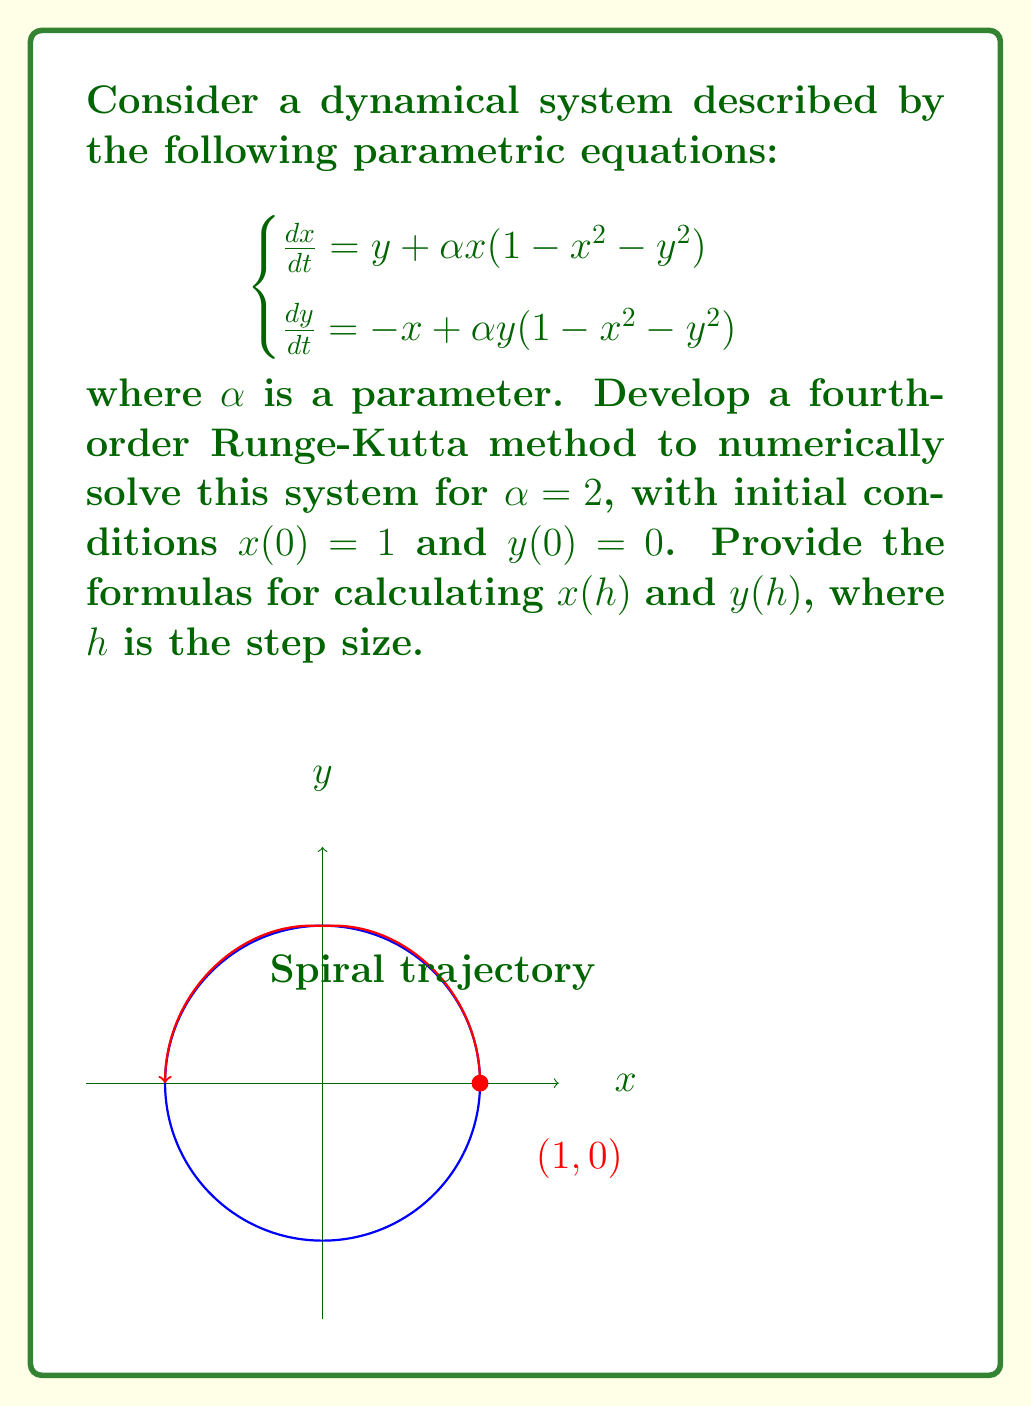Teach me how to tackle this problem. To solve this system using the fourth-order Runge-Kutta method, we follow these steps:

1) Define the functions for $\frac{dx}{dt}$ and $\frac{dy}{dt}$:
   $$f(x,y) = y + 2x(1-x^2-y^2)$$
   $$g(x,y) = -x + 2y(1-x^2-y^2)$$

2) The fourth-order Runge-Kutta method for a system of two equations is given by:
   $$x(t+h) = x(t) + \frac{1}{6}(k_1 + 2k_2 + 2k_3 + k_4)$$
   $$y(t+h) = y(t) + \frac{1}{6}(l_1 + 2l_2 + 2l_3 + l_4)$$

   where:
   $$k_1 = hf(x,y)$$
   $$l_1 = hg(x,y)$$
   $$k_2 = hf(x+\frac{1}{2}k_1, y+\frac{1}{2}l_1)$$
   $$l_2 = hg(x+\frac{1}{2}k_1, y+\frac{1}{2}l_1)$$
   $$k_3 = hf(x+\frac{1}{2}k_2, y+\frac{1}{2}l_2)$$
   $$l_3 = hg(x+\frac{1}{2}k_2, y+\frac{1}{2}l_2)$$
   $$k_4 = hf(x+k_3, y+l_3)$$
   $$l_4 = hg(x+k_3, y+l_3)$$

3) Substituting our functions and initial conditions:
   $$k_1 = h[0 + 2(1)(1-1^2-0^2)] = 0$$
   $$l_1 = h[-1 + 2(0)(1-1^2-0^2)] = -h$$
   $$k_2 = h[(0-\frac{h}{2}) + 2(1)(1-1^2-(-\frac{h}{2})^2)] = h(-\frac{h}{2}+2+\frac{h^2}{2})$$
   $$l_2 = h[(-1) + 2(-\frac{h}{2})(1-1^2-(-\frac{h}{2})^2)] = h(-1-h+\frac{h^3}{4})$$

   The expressions for $k_3$, $l_3$, $k_4$, and $l_4$ become increasingly complex, so we'll leave them in terms of $h$.

4) The final formulas for $x(h)$ and $y(h)$ are:
   $$x(h) = 1 + \frac{1}{6}(k_1 + 2k_2 + 2k_3 + k_4)$$
   $$y(h) = 0 + \frac{1}{6}(l_1 + 2l_2 + 2l_3 + l_4)$$

These formulas provide a fourth-order approximation of the solution at $t=h$.
Answer: $$x(h) = 1 + \frac{1}{6}(k_1 + 2k_2 + 2k_3 + k_4)$$
$$y(h) = \frac{1}{6}(l_1 + 2l_2 + 2l_3 + l_4)$$
where $k_i$ and $l_i$ are as defined in the Runge-Kutta method. 